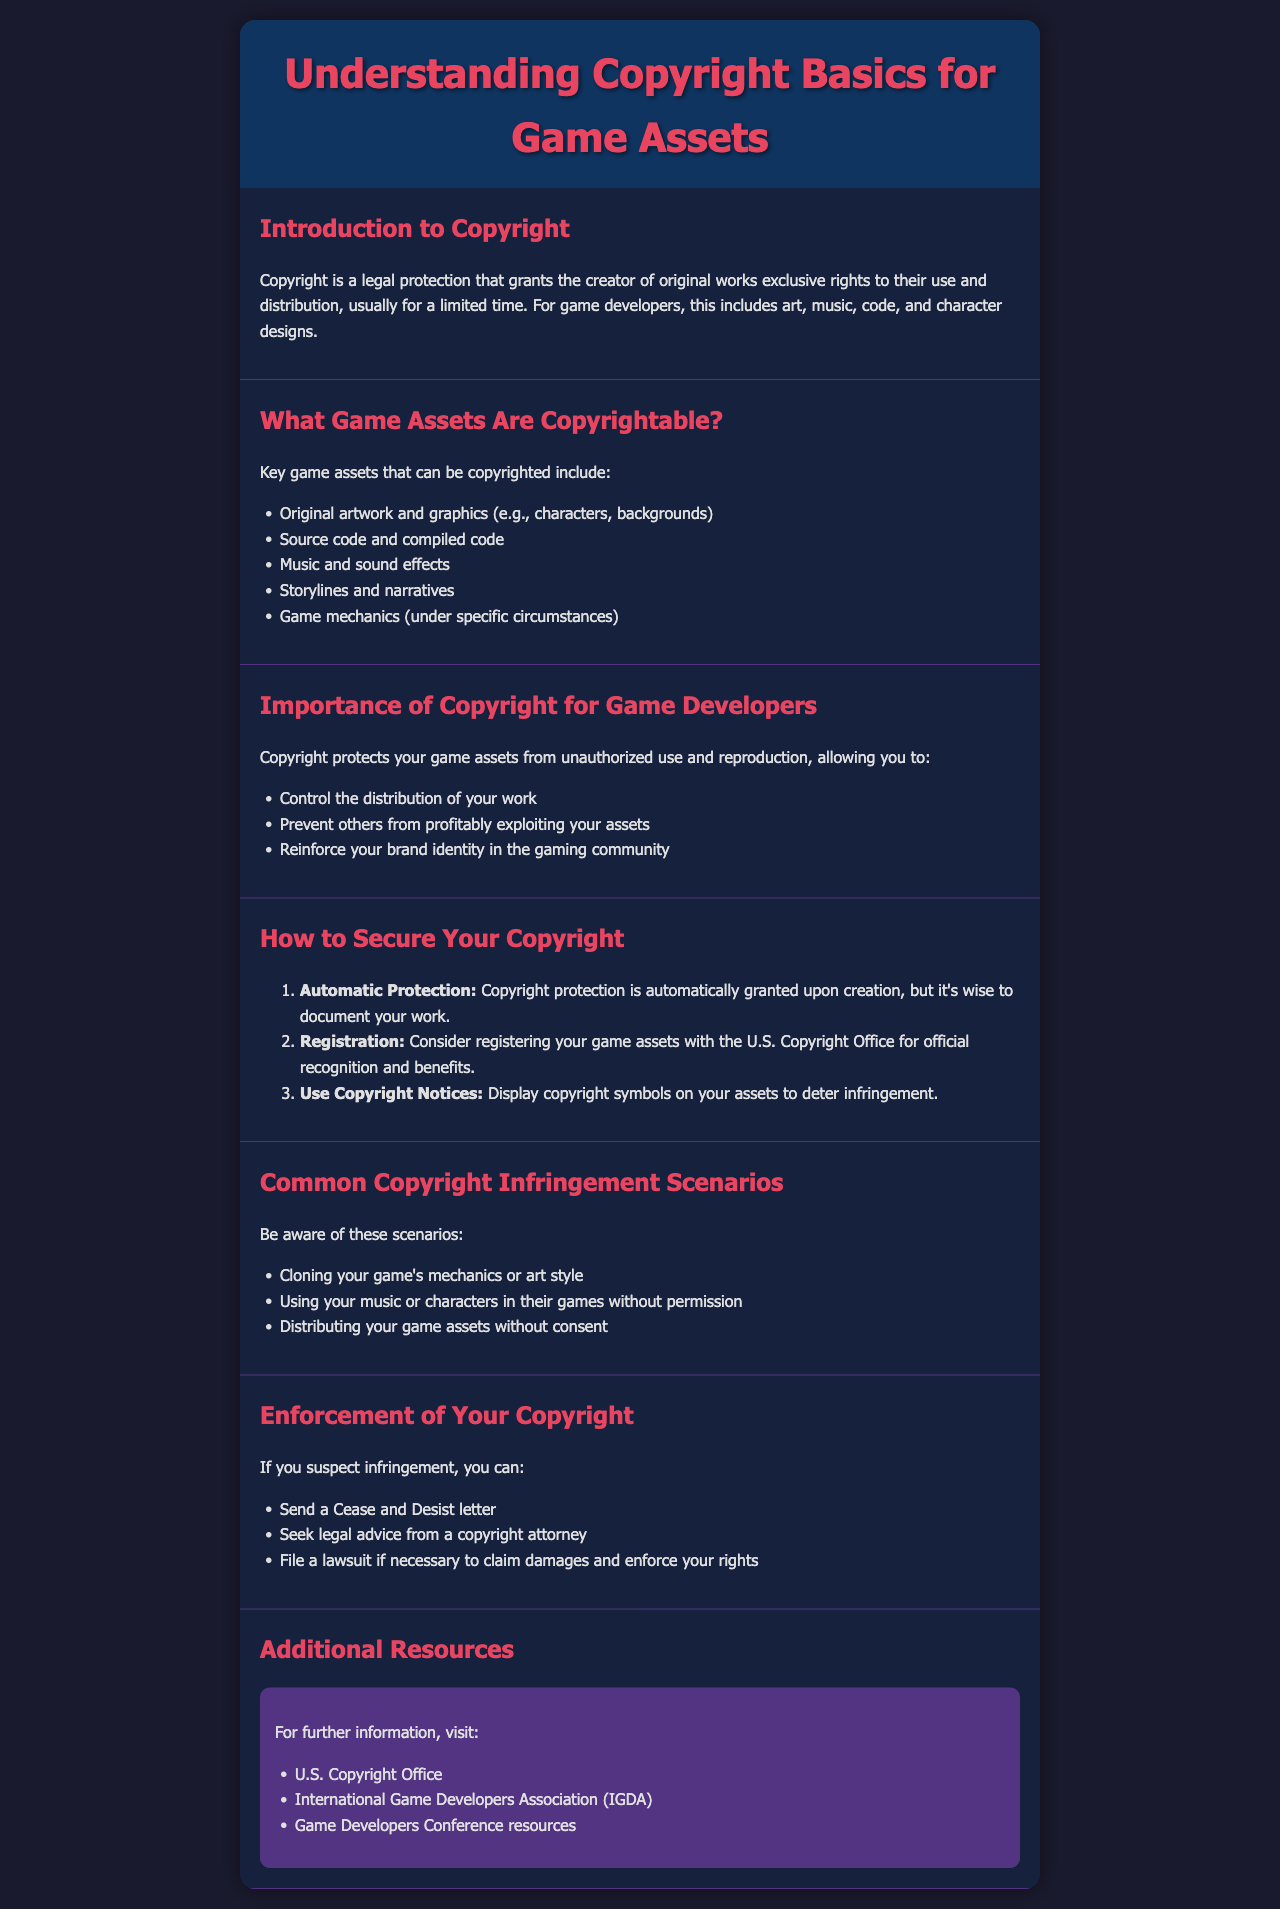What is copyright? Copyright is a legal protection that grants the creator of original works exclusive rights to their use and distribution.
Answer: Legal protection What can be copyrighted in games? The document lists specific game assets that may be copyrightable, such as original artwork, code, music, and storylines.
Answer: Artwork, code, music, storylines What should you do to secure your copyright? To secure your copyright, the document provides steps including automatic protection, registration, and using copyright notices.
Answer: Automatic protection, registration, copyright notices What is a common infringement scenario for game developers? The document lists scenarios such as cloning game mechanics or art style and using music or characters without permission.
Answer: Cloning game mechanics What can you do if you suspect copyright infringement? The document suggests actions like sending a Cease and Desist letter and seeking legal advice.
Answer: Send a Cease and Desist letter What is one benefit of copyright for game developers? The document specifies that copyright protects your game assets from unauthorized use and reproduction.
Answer: Protects from unauthorized use What is one resource for further information on copyright? The document references the U.S. Copyright Office as a resource.
Answer: U.S. Copyright Office What type of assets does copyright protect? Copyright protects original works, including art, music, and code.
Answer: Original works How can you prevent others from exploiting your game assets? The document mentions that copyright allows you to control the distribution of your work.
Answer: Control distribution 